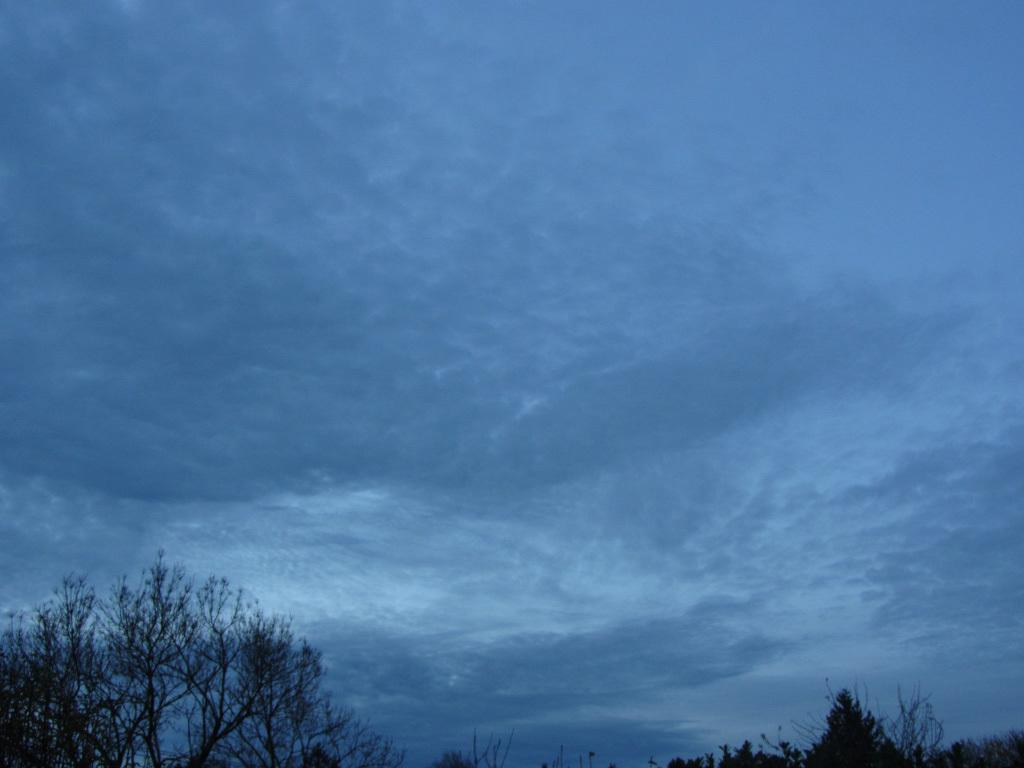What can be seen at the top of the image? The sky is visible in the image. How does the sky look in the image? The sky appears cloudy in the image. What is located at the bottom of the image? There is a group of trees at the bottom of the image. What type of popcorn is being used to create the clouds in the image? There is no popcorn present in the image, and the clouds are not made of popcorn. What fictional character can be seen interacting with the trees in the image? There are no fictional characters present in the image, and the trees are not interacting with any characters. 